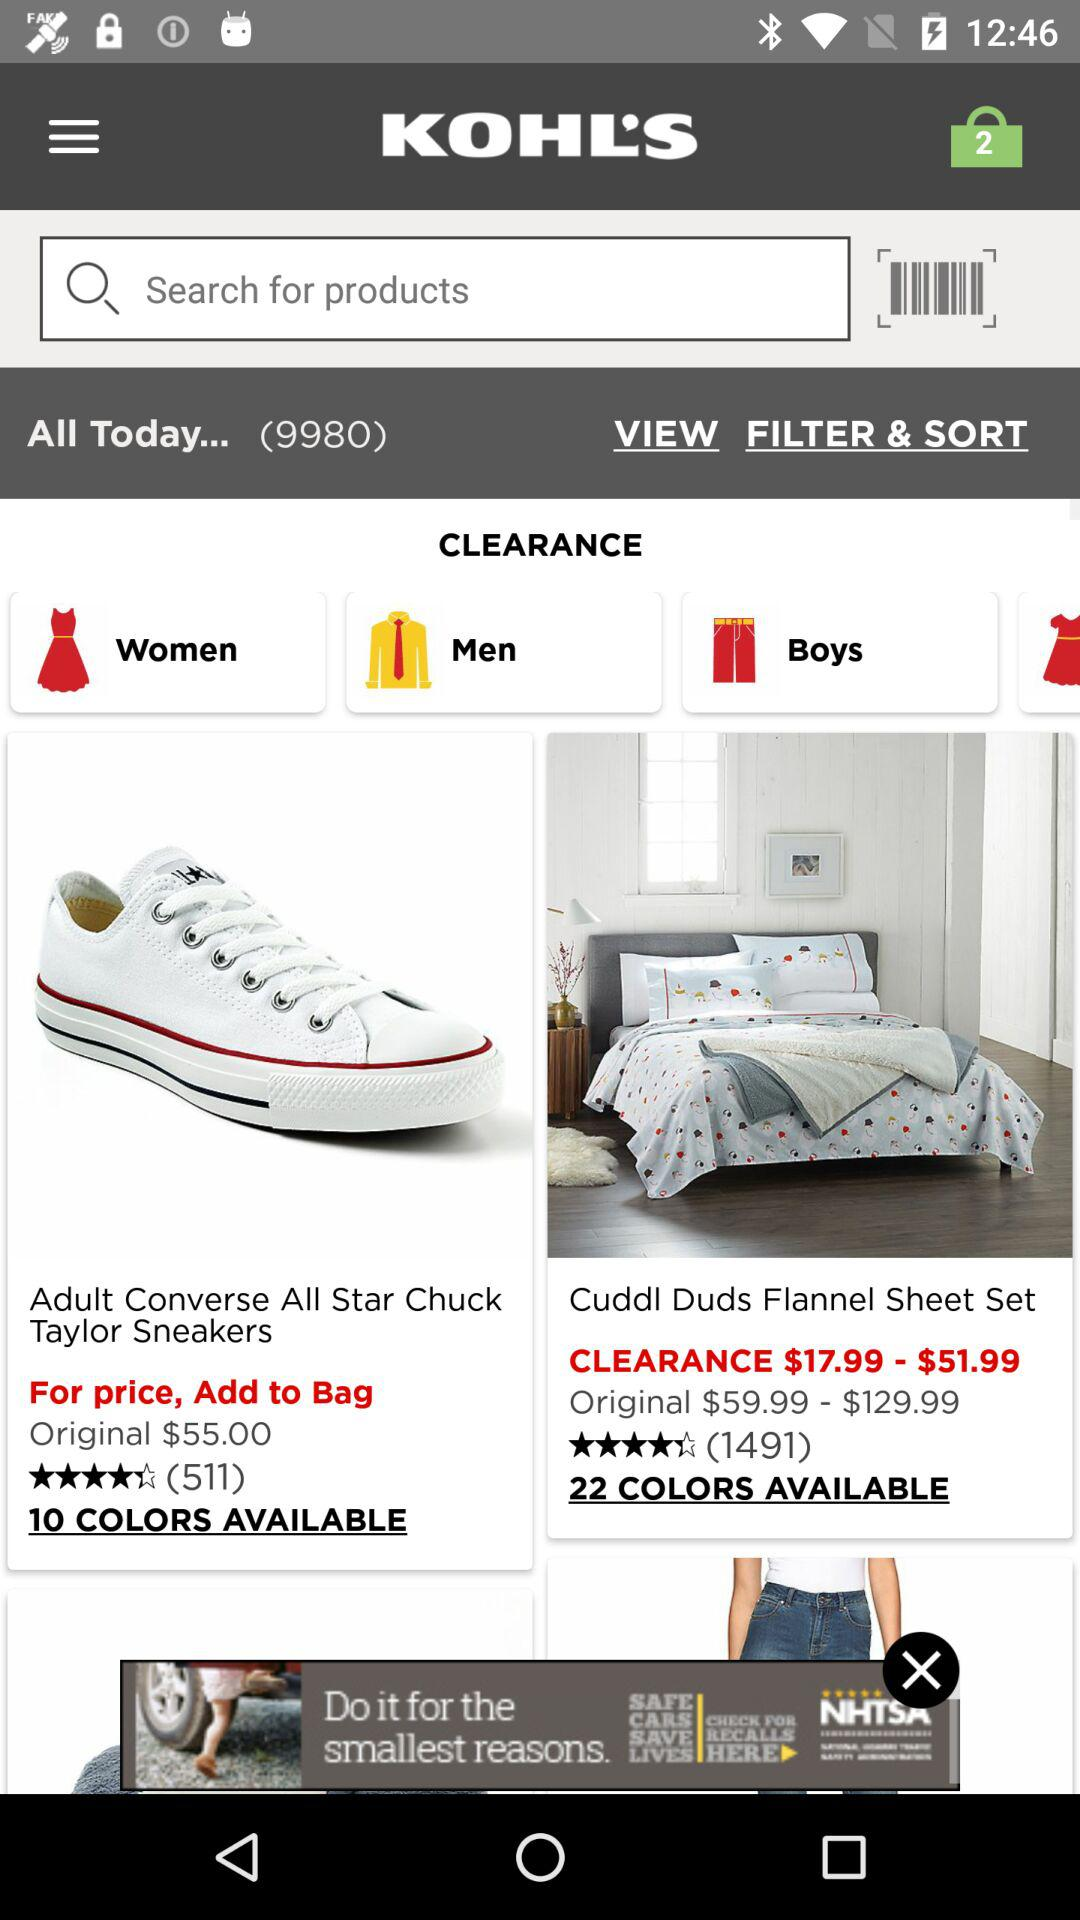What is count of products?
When the provided information is insufficient, respond with <no answer>. <no answer> 